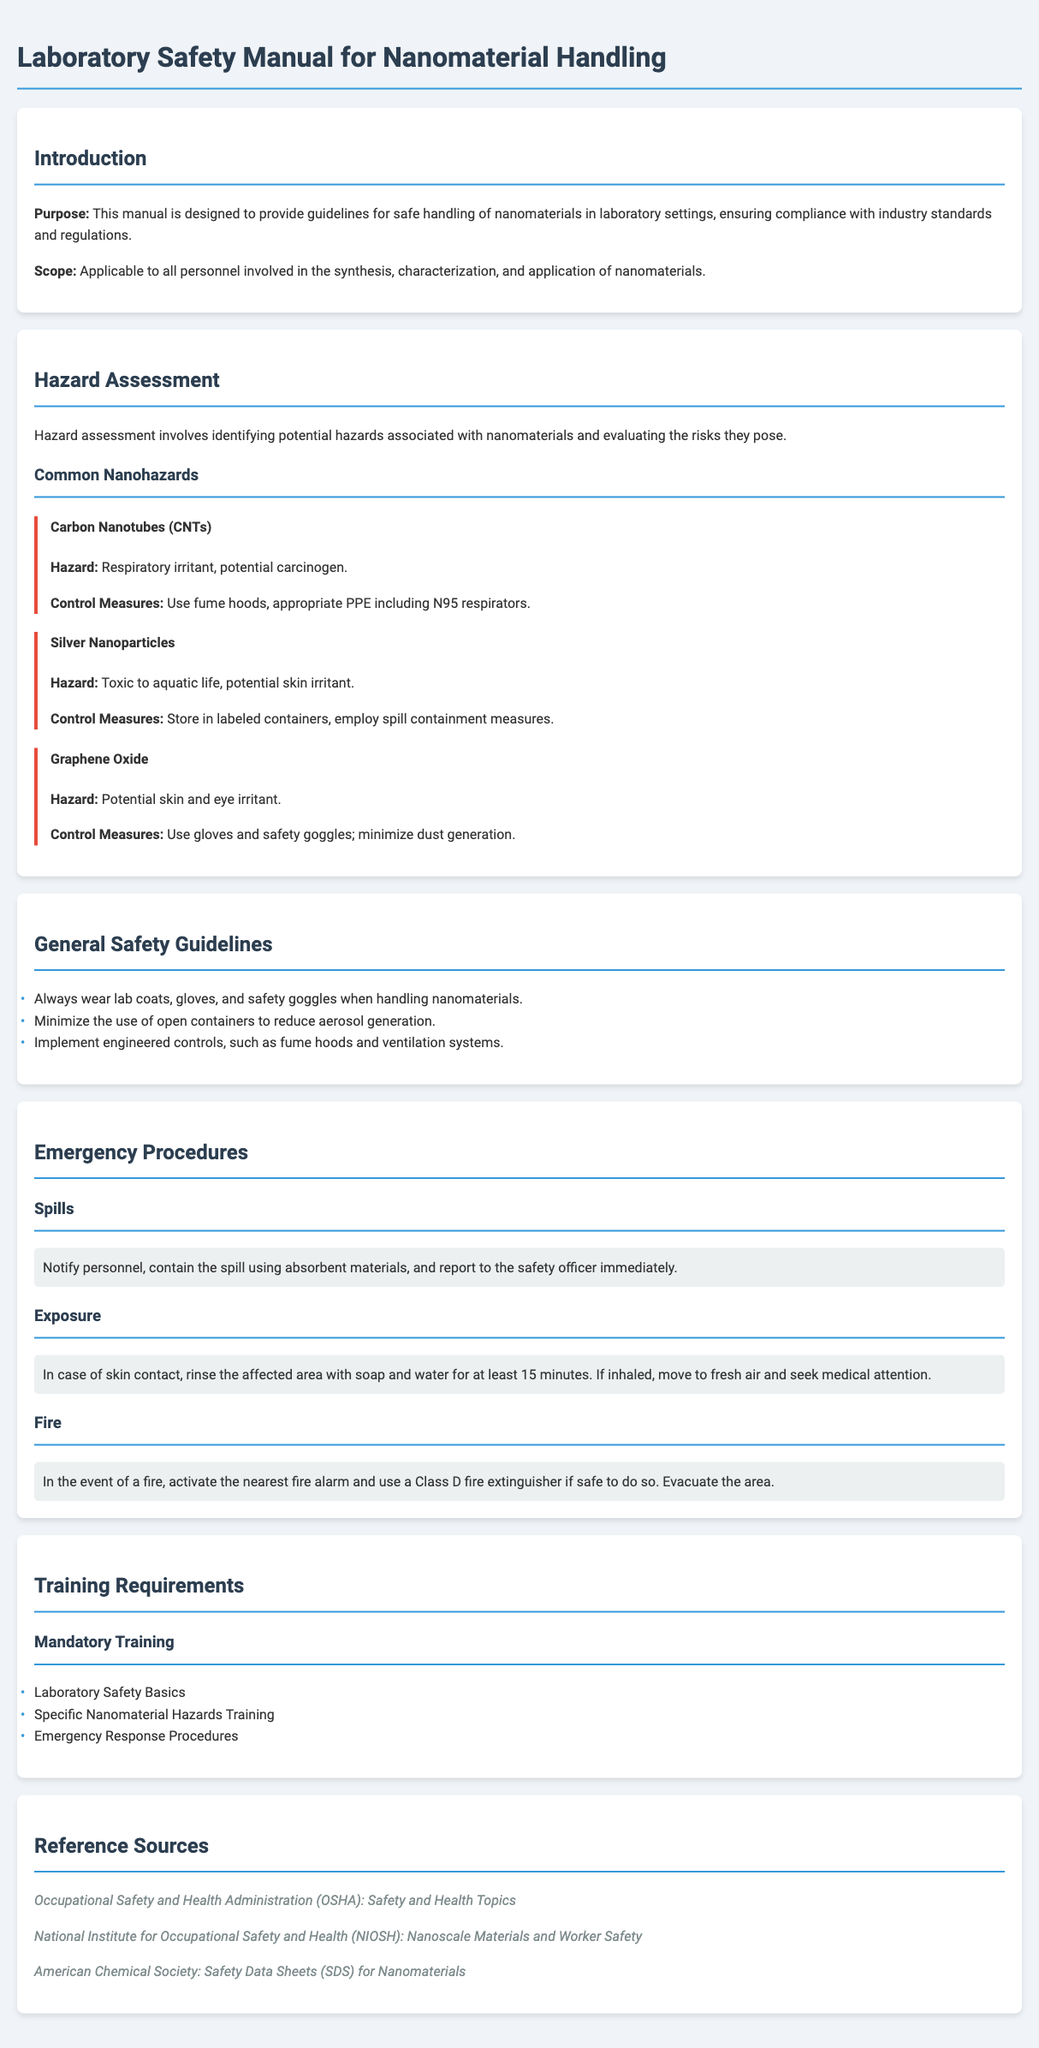What is the purpose of this manual? The purpose is to provide guidelines for safe handling of nanomaterials in laboratory settings, ensuring compliance with industry standards and regulations.
Answer: To provide guidelines for safe handling of nanomaterials What type of hazards are assessed in the document? Hazards assessed include respiratory irritants and potential carcinogens among others mentioned in the hazards section.
Answer: Respiratory irritants, potential carcinogens What are the control measures for carbon nanotubes? The control measures for carbon nanotubes include using fume hoods and appropriate personal protective equipment like N95 respirators.
Answer: Use fume hoods, N95 respirators How long should you rinse the affected area in case of skin contact? The document specifies rinsing the affected area with soap and water for at least 15 minutes in the event of skin contact.
Answer: At least 15 minutes Which fire extinguisher should be used in case of a fire? The appropriate extinguisher mentioned in the emergency procedures is a Class D fire extinguisher.
Answer: Class D fire extinguisher How many types of mandatory training are listed? The document lists three types of mandatory training required for personnel handling nanomaterials.
Answer: Three What are the common hazards associated with silver nanoparticles? The common hazards include being toxic to aquatic life and a potential skin irritant as stated in the document.
Answer: Toxic to aquatic life, potential skin irritant What item is suggested for containing spills? The recommended item for containing spills involves using absorbent materials as stated in the emergency procedures section.
Answer: Absorbent materials 